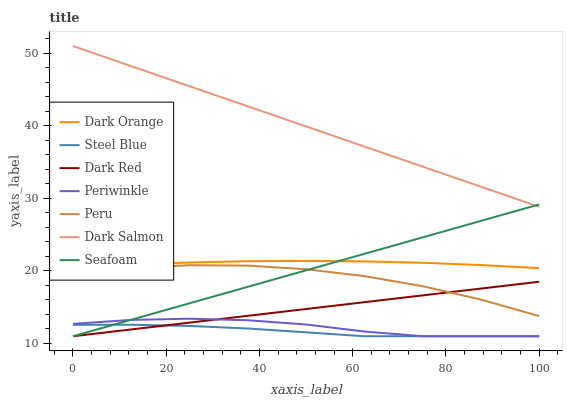Does Steel Blue have the minimum area under the curve?
Answer yes or no. Yes. Does Dark Salmon have the maximum area under the curve?
Answer yes or no. Yes. Does Seafoam have the minimum area under the curve?
Answer yes or no. No. Does Seafoam have the maximum area under the curve?
Answer yes or no. No. Is Dark Salmon the smoothest?
Answer yes or no. Yes. Is Peru the roughest?
Answer yes or no. Yes. Is Seafoam the smoothest?
Answer yes or no. No. Is Seafoam the roughest?
Answer yes or no. No. Does Seafoam have the lowest value?
Answer yes or no. Yes. Does Dark Salmon have the lowest value?
Answer yes or no. No. Does Dark Salmon have the highest value?
Answer yes or no. Yes. Does Seafoam have the highest value?
Answer yes or no. No. Is Steel Blue less than Dark Orange?
Answer yes or no. Yes. Is Dark Salmon greater than Dark Orange?
Answer yes or no. Yes. Does Periwinkle intersect Seafoam?
Answer yes or no. Yes. Is Periwinkle less than Seafoam?
Answer yes or no. No. Is Periwinkle greater than Seafoam?
Answer yes or no. No. Does Steel Blue intersect Dark Orange?
Answer yes or no. No. 